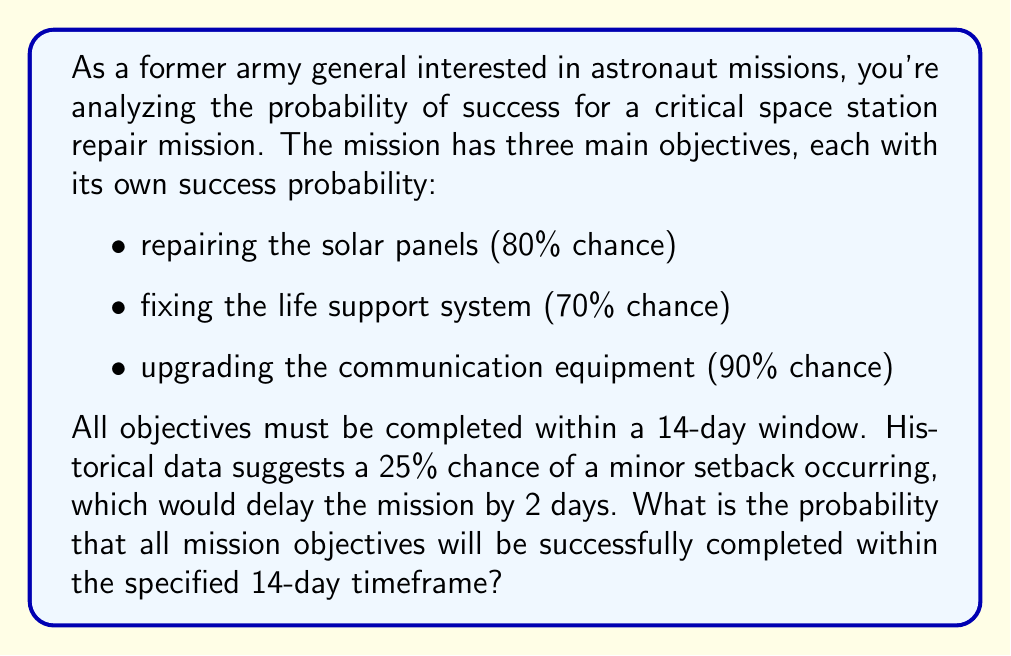Teach me how to tackle this problem. Let's approach this step-by-step:

1) First, we need to calculate the probability of successfully completing all three objectives:
   $$P(\text{all objectives}) = 0.80 \times 0.70 \times 0.90 = 0.504 = 50.4\%$$

2) Now, we need to consider the probability of completing the mission within the timeframe. There are two scenarios:
   a) No setback occurs (75% chance)
   b) A setback occurs (25% chance), but there's still enough time to complete the mission

3) If a setback occurs, it delays the mission by 2 days, leaving 12 days. Since the original timeframe was 14 days, this is still sufficient to complete the mission.

4) Therefore, the probability of completing the mission within the timeframe is 100%, or 1.

5) We can now combine these probabilities:
   $$P(\text{success}) = P(\text{all objectives}) \times P(\text{within timeframe})$$
   $$P(\text{success}) = 0.504 \times 1 = 0.504$$

Thus, the probability of successfully completing all mission objectives within the specified timeframe is 0.504 or 50.4%.
Answer: The probability of successfully completing all mission objectives within the specified 14-day timeframe is 0.504 or 50.4%. 